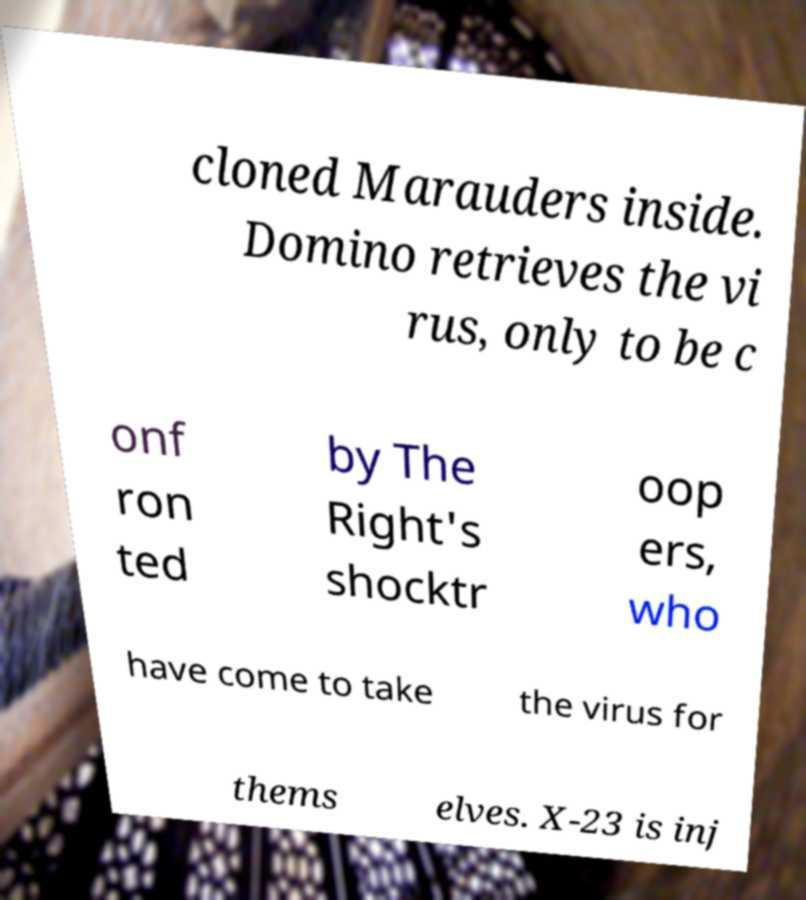There's text embedded in this image that I need extracted. Can you transcribe it verbatim? cloned Marauders inside. Domino retrieves the vi rus, only to be c onf ron ted by The Right's shocktr oop ers, who have come to take the virus for thems elves. X-23 is inj 